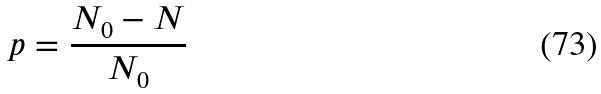<formula> <loc_0><loc_0><loc_500><loc_500>p = \frac { N _ { 0 } - N } { N _ { 0 } }</formula> 